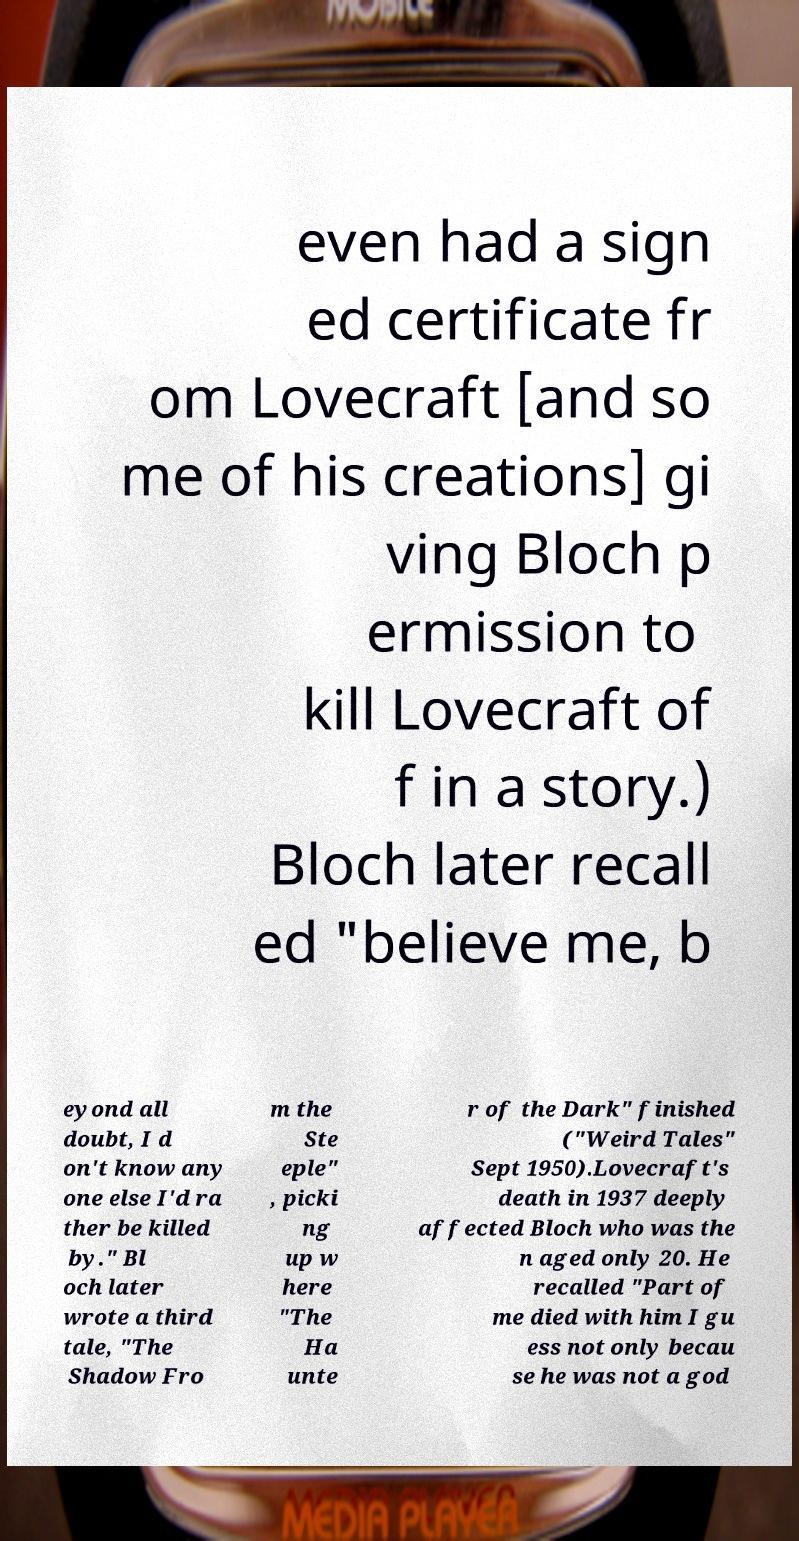Please read and relay the text visible in this image. What does it say? even had a sign ed certificate fr om Lovecraft [and so me of his creations] gi ving Bloch p ermission to kill Lovecraft of f in a story.) Bloch later recall ed "believe me, b eyond all doubt, I d on't know any one else I'd ra ther be killed by." Bl och later wrote a third tale, "The Shadow Fro m the Ste eple" , picki ng up w here "The Ha unte r of the Dark" finished ("Weird Tales" Sept 1950).Lovecraft's death in 1937 deeply affected Bloch who was the n aged only 20. He recalled "Part of me died with him I gu ess not only becau se he was not a god 